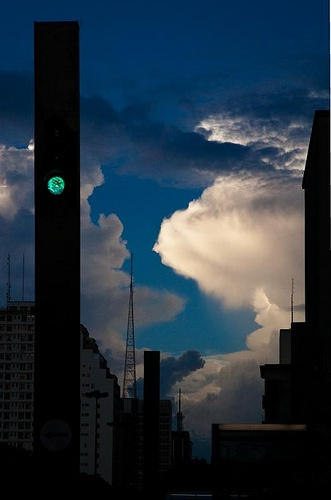Describe the objects in this image and their specific colors. I can see a traffic light in navy, black, teal, and turquoise tones in this image. 